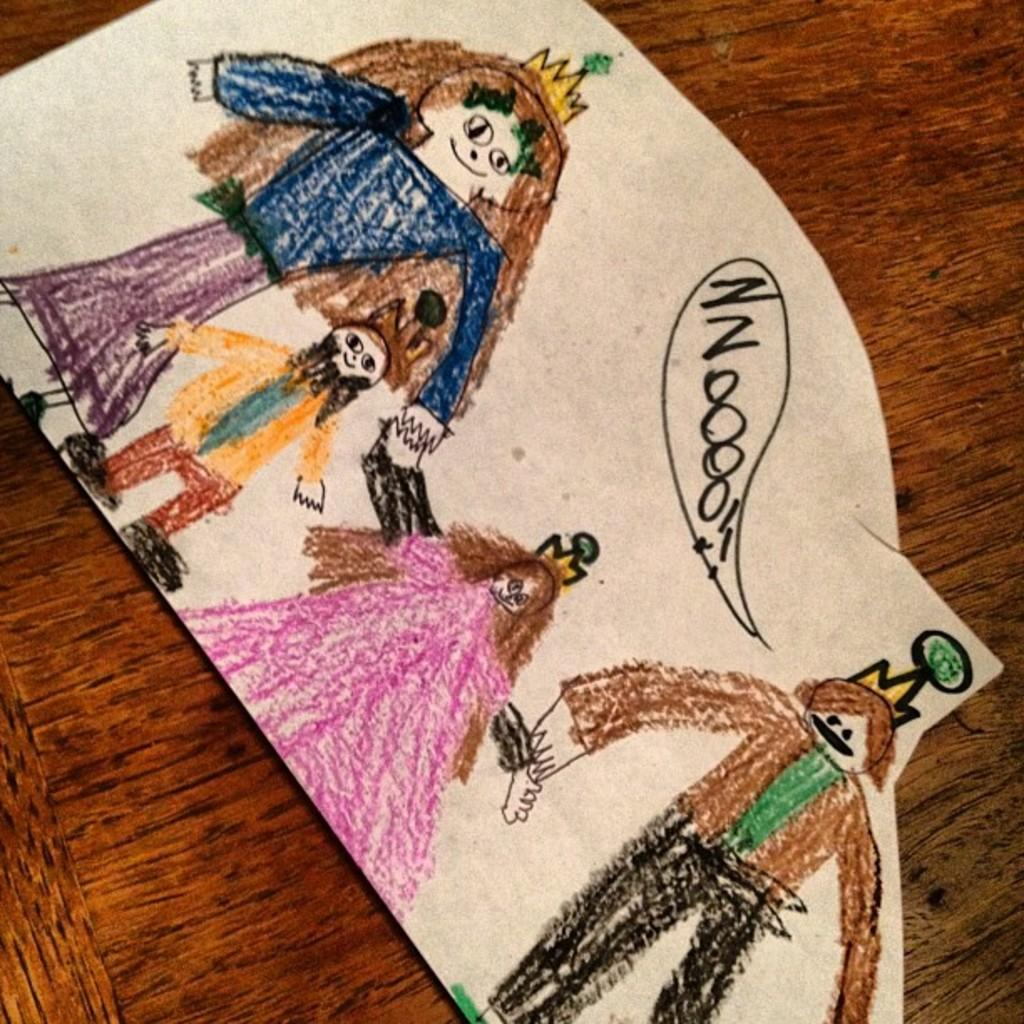What is depicted on the paper in the image? There are drawings on a paper in the image. What type of object is the paper placed on? The paper is on a wooden object. What type of pie is being served on the wooden object in the image? There is no pie present in the image; it features drawings on a paper placed on a wooden object. 